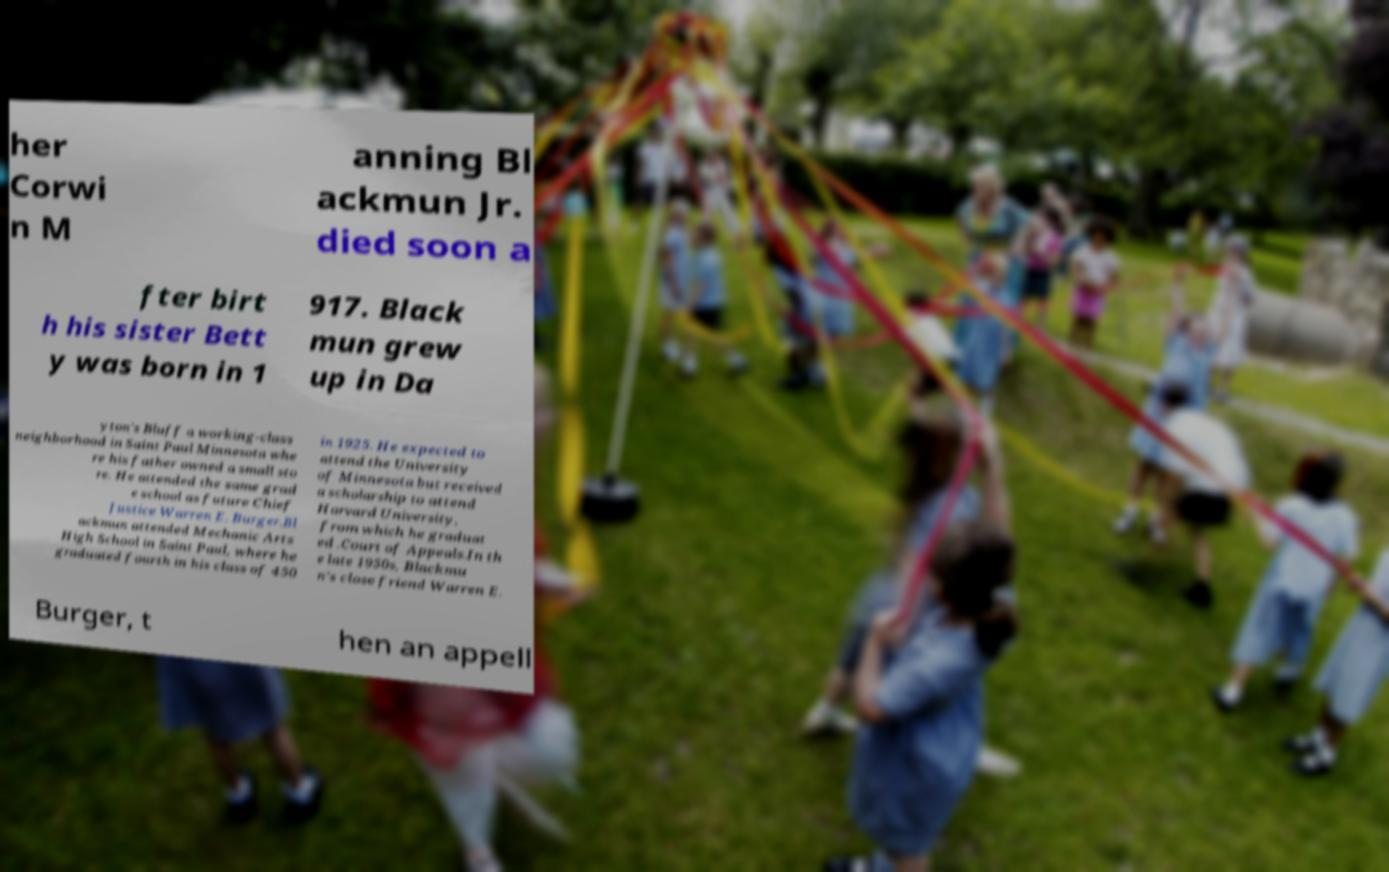For documentation purposes, I need the text within this image transcribed. Could you provide that? her Corwi n M anning Bl ackmun Jr. died soon a fter birt h his sister Bett y was born in 1 917. Black mun grew up in Da yton's Bluff a working-class neighborhood in Saint Paul Minnesota whe re his father owned a small sto re. He attended the same grad e school as future Chief Justice Warren E. Burger.Bl ackmun attended Mechanic Arts High School in Saint Paul, where he graduated fourth in his class of 450 in 1925. He expected to attend the University of Minnesota but received a scholarship to attend Harvard University, from which he graduat ed .Court of Appeals.In th e late 1950s, Blackmu n's close friend Warren E. Burger, t hen an appell 